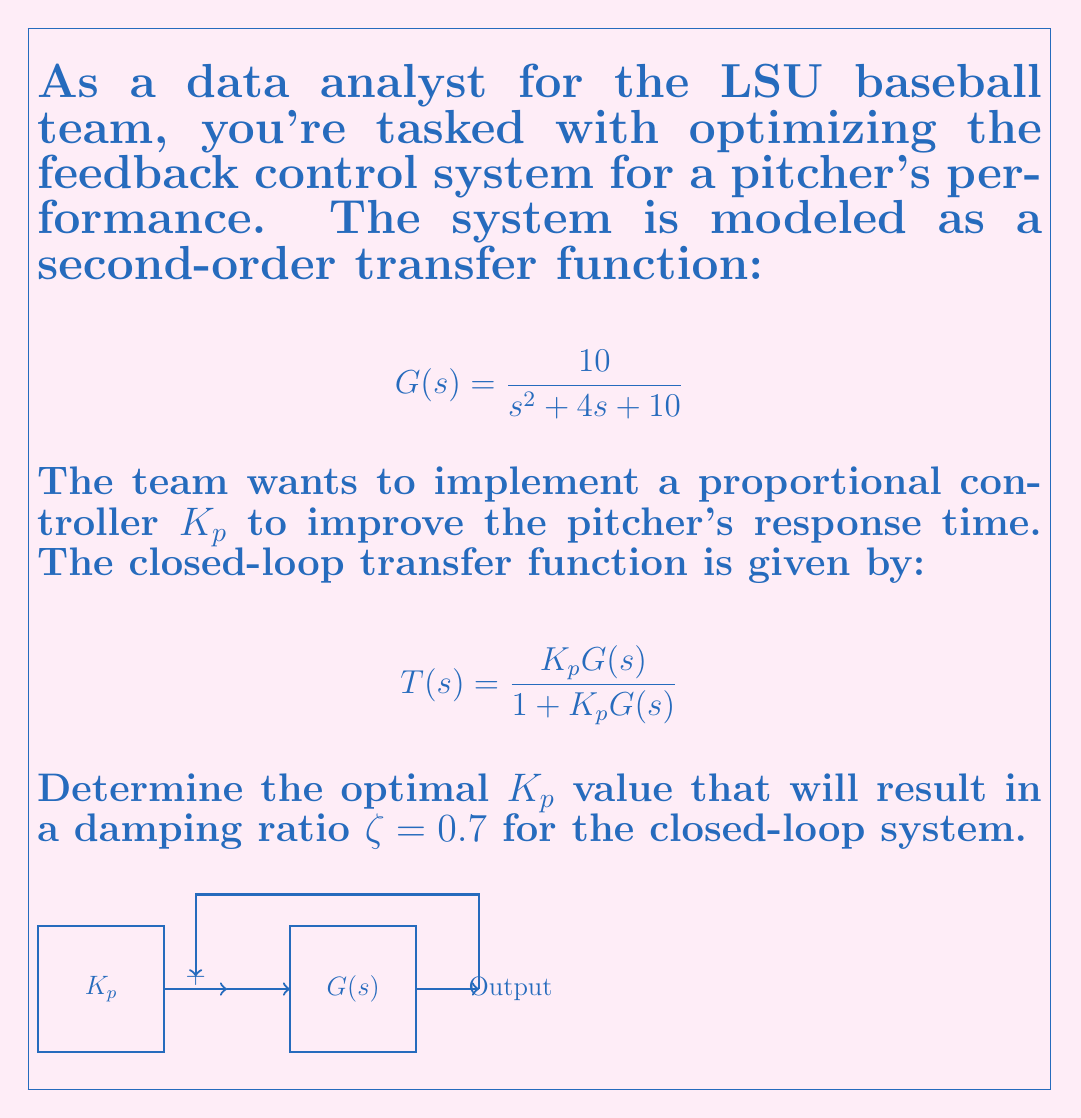Give your solution to this math problem. To solve this problem, we'll follow these steps:

1) The closed-loop transfer function is:

   $$T(s) = \frac{10K_p}{s^2 + 4s + 10 + 10K_p}$$

2) The standard form of a second-order system is:

   $$T(s) = \frac{\omega_n^2}{s^2 + 2\zeta\omega_n s + \omega_n^2}$$

3) Comparing our closed-loop transfer function with the standard form:

   $$\omega_n^2 = 10 + 10K_p$$
   $$2\zeta\omega_n = 4$$

4) We're given that $\zeta = 0.7$. Substituting this into the second equation:

   $$2(0.7)\omega_n = 4$$
   $$\omega_n = \frac{4}{1.4} \approx 2.8571$$

5) Now we can use this $\omega_n$ value in the first equation:

   $$2.8571^2 = 10 + 10K_p$$
   $$8.1631 = 10 + 10K_p$$

6) Solving for $K_p$:

   $$10K_p = 8.1631 - 10$$
   $$10K_p = -1.8369$$
   $$K_p = -0.18369$$

7) However, $K_p$ should be positive for a proportional controller. Let's use the positive solution:

   $$K_p = 0.18369$$
Answer: $K_p \approx 0.18369$ 